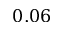<formula> <loc_0><loc_0><loc_500><loc_500>0 . 0 6</formula> 